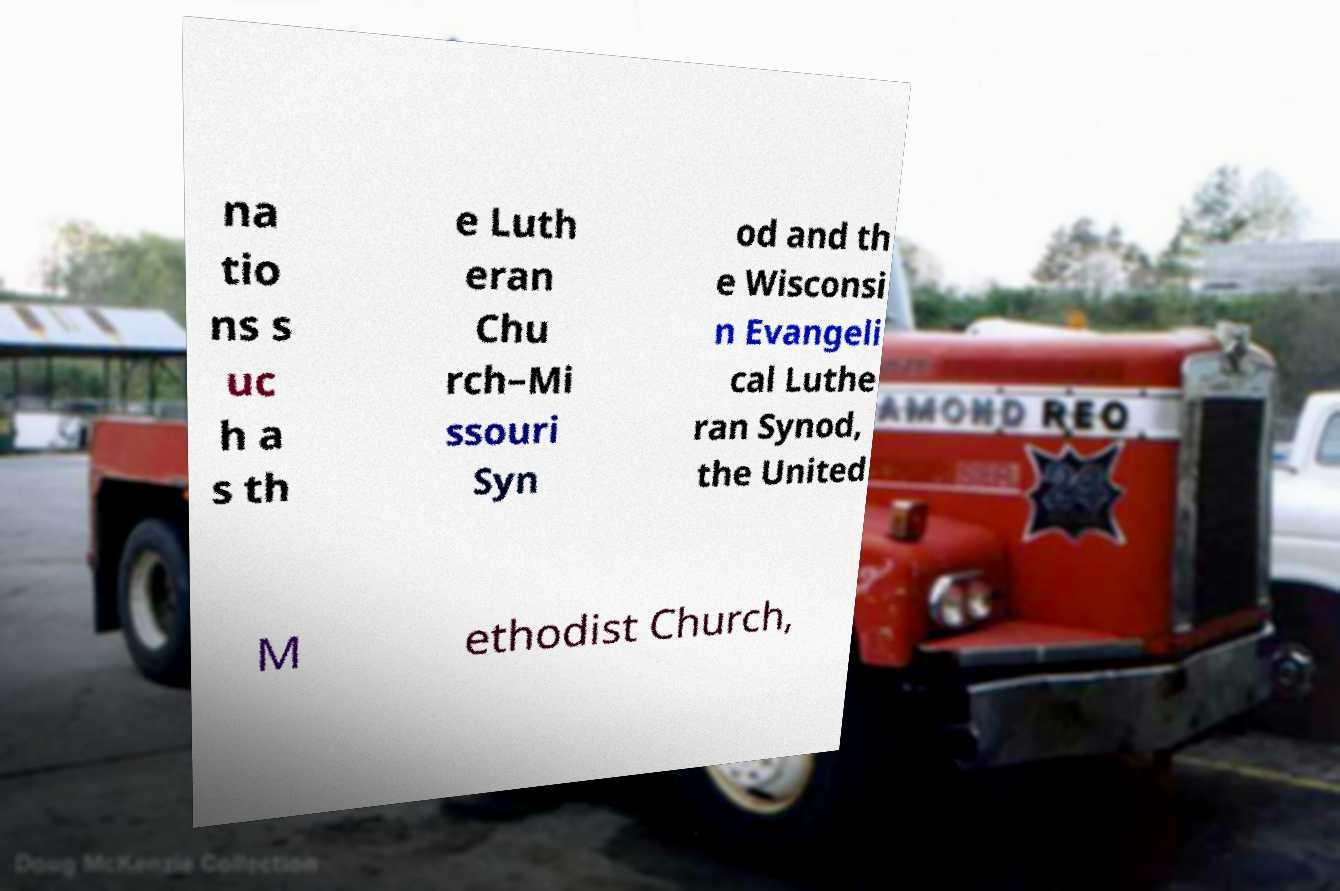Please read and relay the text visible in this image. What does it say? na tio ns s uc h a s th e Luth eran Chu rch–Mi ssouri Syn od and th e Wisconsi n Evangeli cal Luthe ran Synod, the United M ethodist Church, 